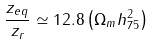Convert formula to latex. <formula><loc_0><loc_0><loc_500><loc_500>\frac { z _ { e q } } { z _ { r } } \simeq 1 2 . 8 \left ( \Omega _ { m } h _ { 7 5 } ^ { 2 } \right )</formula> 